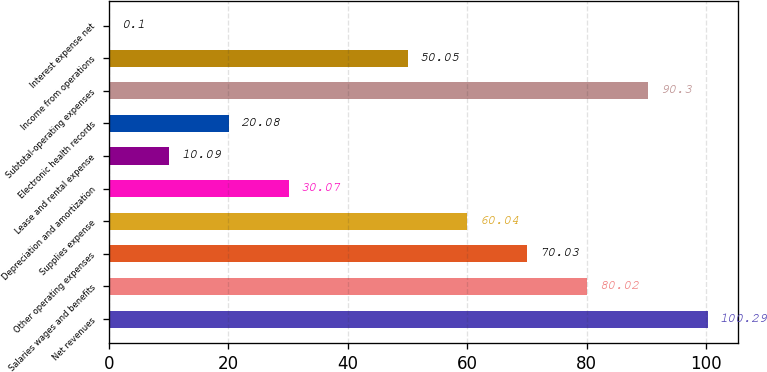Convert chart. <chart><loc_0><loc_0><loc_500><loc_500><bar_chart><fcel>Net revenues<fcel>Salaries wages and benefits<fcel>Other operating expenses<fcel>Supplies expense<fcel>Depreciation and amortization<fcel>Lease and rental expense<fcel>Electronic health records<fcel>Subtotal-operating expenses<fcel>Income from operations<fcel>Interest expense net<nl><fcel>100.29<fcel>80.02<fcel>70.03<fcel>60.04<fcel>30.07<fcel>10.09<fcel>20.08<fcel>90.3<fcel>50.05<fcel>0.1<nl></chart> 